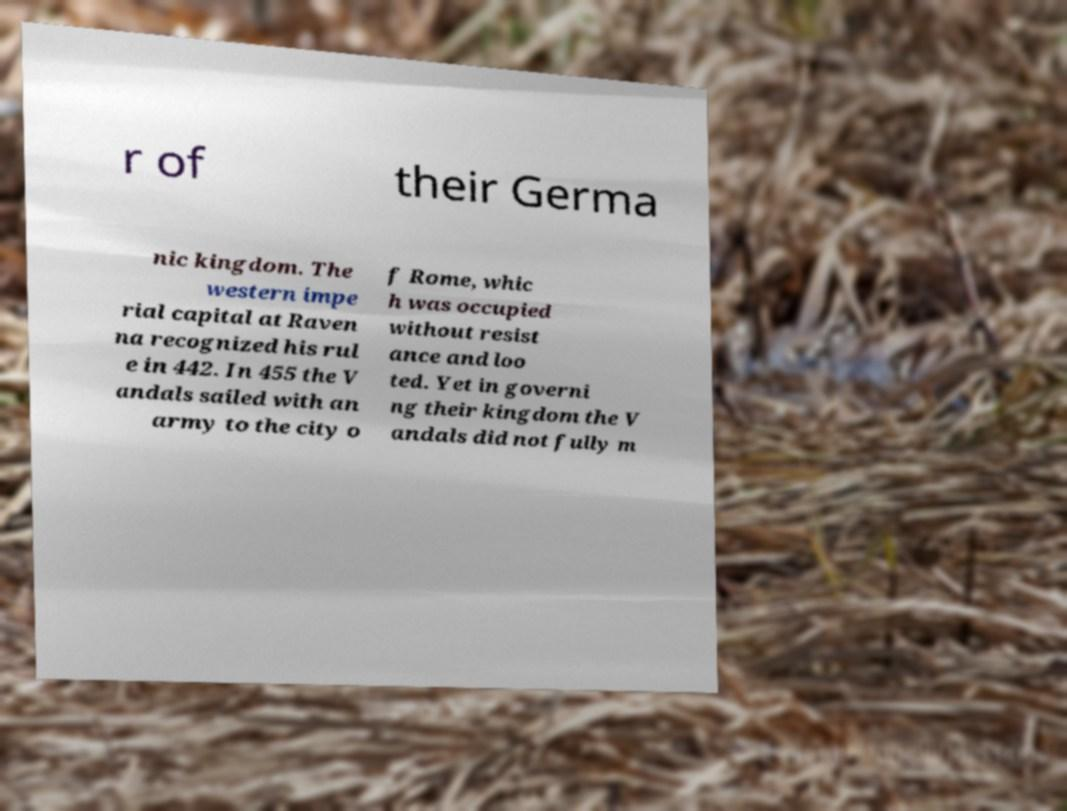I need the written content from this picture converted into text. Can you do that? r of their Germa nic kingdom. The western impe rial capital at Raven na recognized his rul e in 442. In 455 the V andals sailed with an army to the city o f Rome, whic h was occupied without resist ance and loo ted. Yet in governi ng their kingdom the V andals did not fully m 